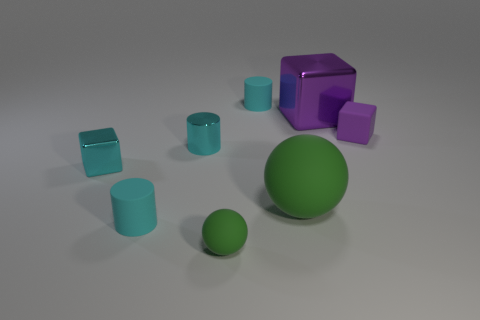What material is the big object that is the same shape as the small purple thing? The large object sharing the shape with the small purple item appears to be made of a matte material with properties similar to plastic or ceramic, based on its visual texture and light reflection characteristics. 